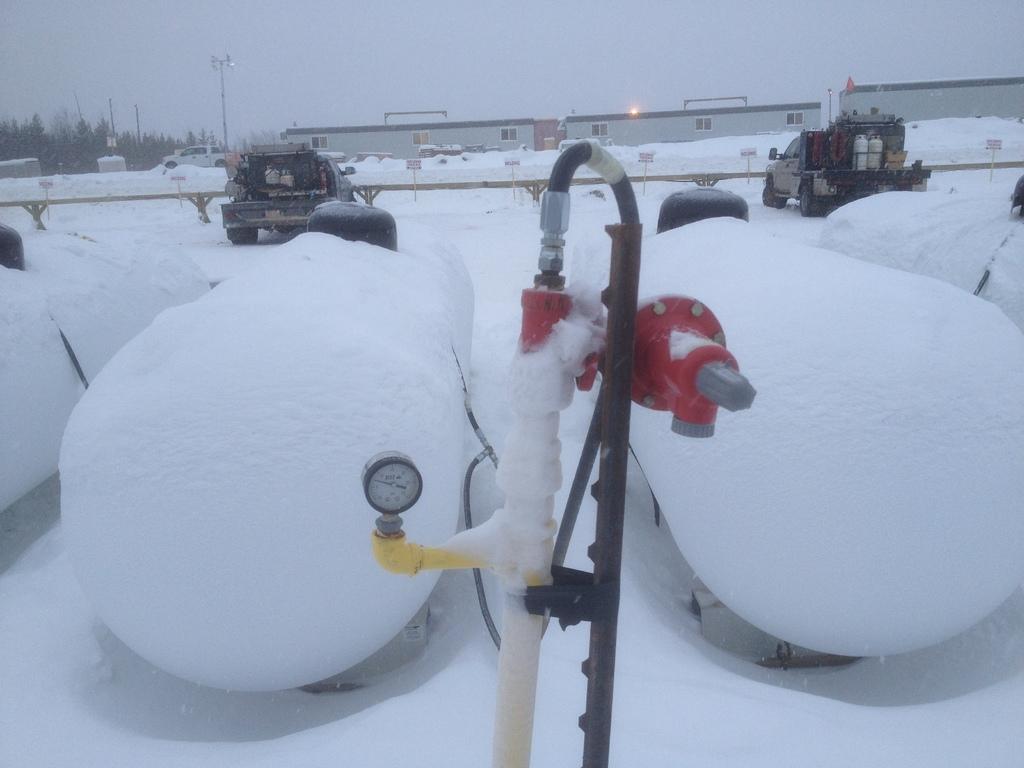Please provide a concise description of this image. In this image I can see snow, gauge, pipes, vehicles, railing, boards, poles, buildings, sunlight, trees, sky and objects. 